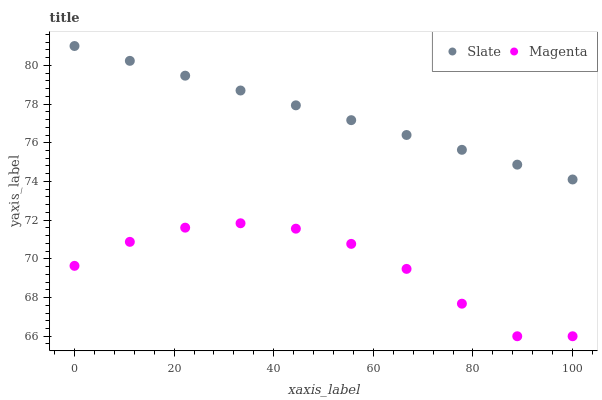Does Magenta have the minimum area under the curve?
Answer yes or no. Yes. Does Slate have the maximum area under the curve?
Answer yes or no. Yes. Does Magenta have the maximum area under the curve?
Answer yes or no. No. Is Slate the smoothest?
Answer yes or no. Yes. Is Magenta the roughest?
Answer yes or no. Yes. Is Magenta the smoothest?
Answer yes or no. No. Does Magenta have the lowest value?
Answer yes or no. Yes. Does Slate have the highest value?
Answer yes or no. Yes. Does Magenta have the highest value?
Answer yes or no. No. Is Magenta less than Slate?
Answer yes or no. Yes. Is Slate greater than Magenta?
Answer yes or no. Yes. Does Magenta intersect Slate?
Answer yes or no. No. 